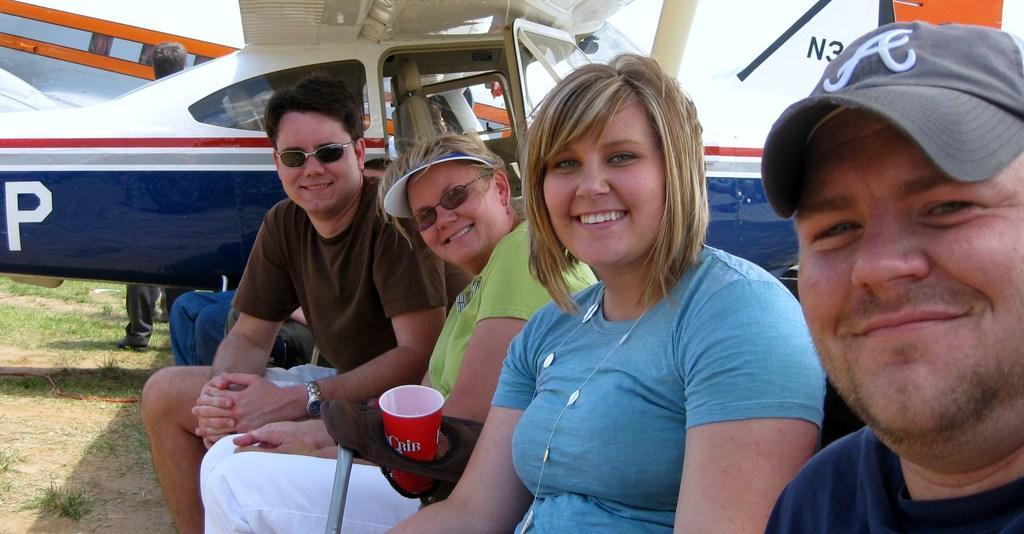Describe this image in one or two sentences. In this image there are group of people sitting on the chairs and smiling, beside them there is a helicopter and also there there is a glass in the the chair. 